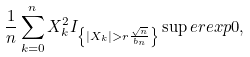Convert formula to latex. <formula><loc_0><loc_0><loc_500><loc_500>\frac { 1 } { n } \sum _ { k = 0 } ^ { n } X _ { k } ^ { 2 } I _ { \left \{ | X _ { k } | > r \frac { \sqrt { n } } { b _ { n } } \right \} } \sup e r e x p 0 ,</formula> 